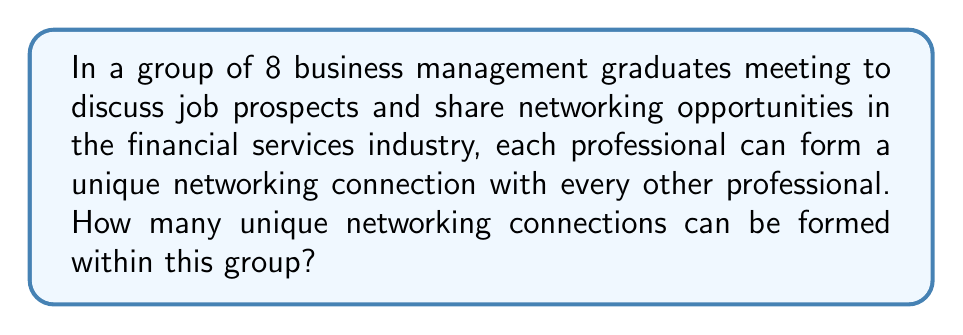Can you solve this math problem? Let's approach this step-by-step:

1) First, we need to recognize that this is a combination problem. Each unique connection is between two professionals, and the order doesn't matter (A connecting with B is the same as B connecting with A).

2) The formula for combinations is:

   $$C(n,r) = \frac{n!}{r!(n-r)!}$$

   where $n$ is the total number of items to choose from, and $r$ is the number of items being chosen.

3) In this case:
   - $n = 8$ (total number of professionals)
   - $r = 2$ (we're choosing 2 professionals for each connection)

4) Plugging these values into our formula:

   $$C(8,2) = \frac{8!}{2!(8-2)!} = \frac{8!}{2!(6)!}$$

5) Expand this:
   
   $$\frac{8 \cdot 7 \cdot 6!}{2 \cdot 1 \cdot 6!}$$

6) The 6! cancels out in the numerator and denominator:

   $$\frac{8 \cdot 7}{2 \cdot 1} = \frac{56}{2} = 28$$

Therefore, there are 28 unique networking connections that can be formed within this group of 8 professionals.
Answer: 28 